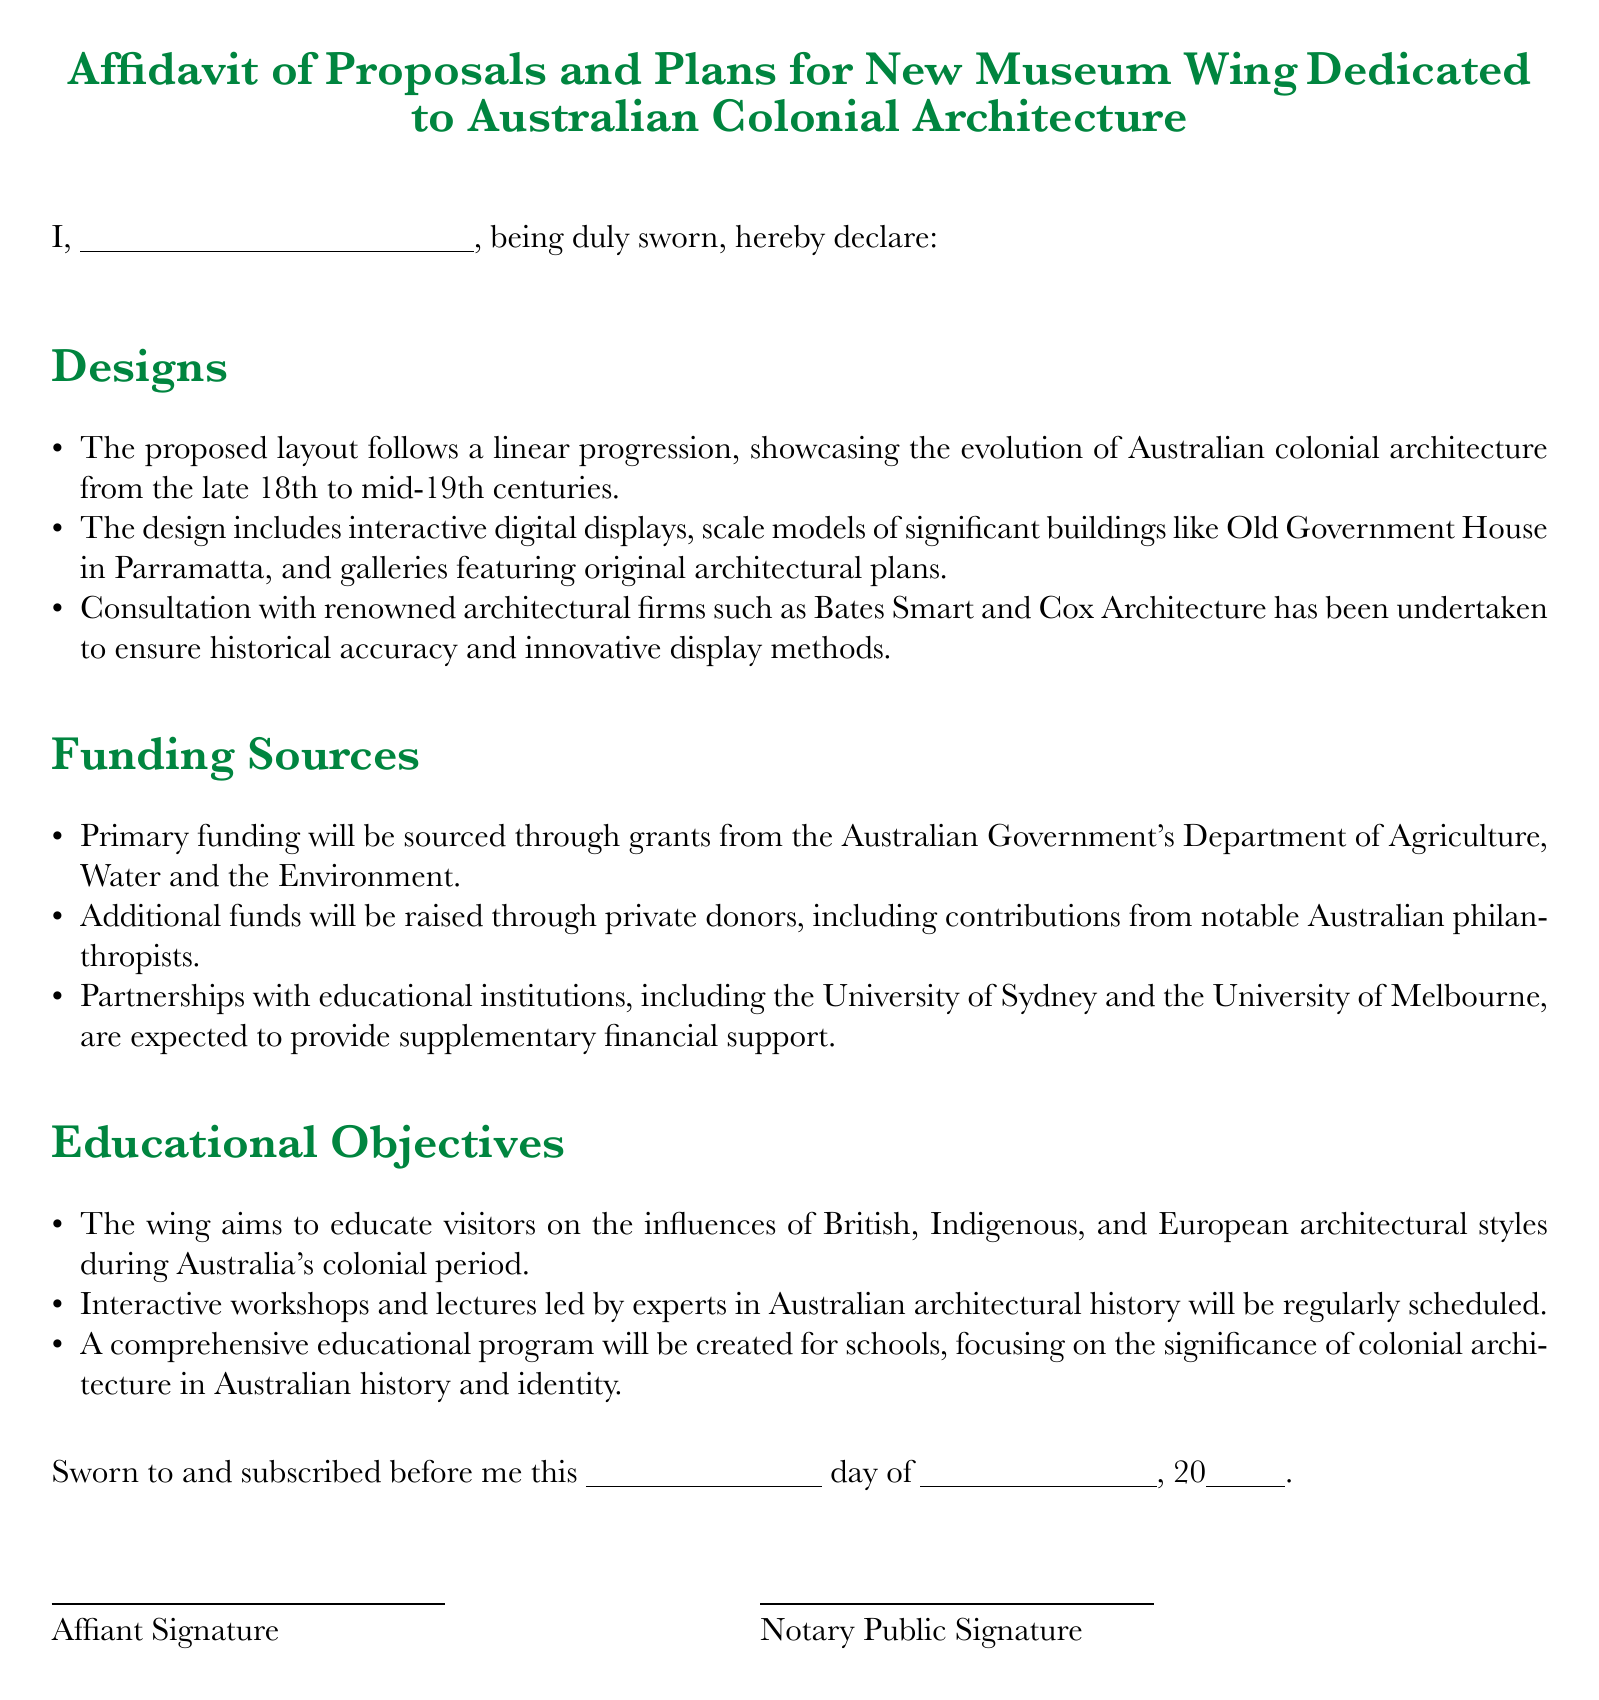What is the main focus of the new museum wing? The main focus of the new museum wing is to showcase Australian colonial architecture.
Answer: Australian colonial architecture Who has been consulted for the design of the museum wing? Renowned architectural firms such as Bates Smart and Cox Architecture have been consulted to ensure historical accuracy.
Answer: Bates Smart and Cox Architecture What is the primary source of funding for the project? The primary funding will be sourced through grants from the Australian Government's Department of Agriculture, Water and the Environment.
Answer: Australian Government's Department of Agriculture, Water and the Environment What types of programs will the museum offer to educate visitors? The museum will offer interactive workshops and lectures led by experts in Australian architectural history.
Answer: Workshops and lectures What significant structures will be included in the scale models? Scale models will feature significant buildings like Old Government House in Parramatta.
Answer: Old Government House in Parramatta When was the affidavit sworn? The specific date the affidavit was sworn is left for the affiant to fill in and is not provided in the document.
Answer: Not specified What aspect of architecture will the educational program focus on? The educational program will focus on the significance of colonial architecture in Australian history and identity.
Answer: Colonial architecture significance Which two universities are mentioned as partners for financial support? Partnerships with educational institutions including the University of Sydney and the University of Melbourne are mentioned.
Answer: University of Sydney and University of Melbourne 